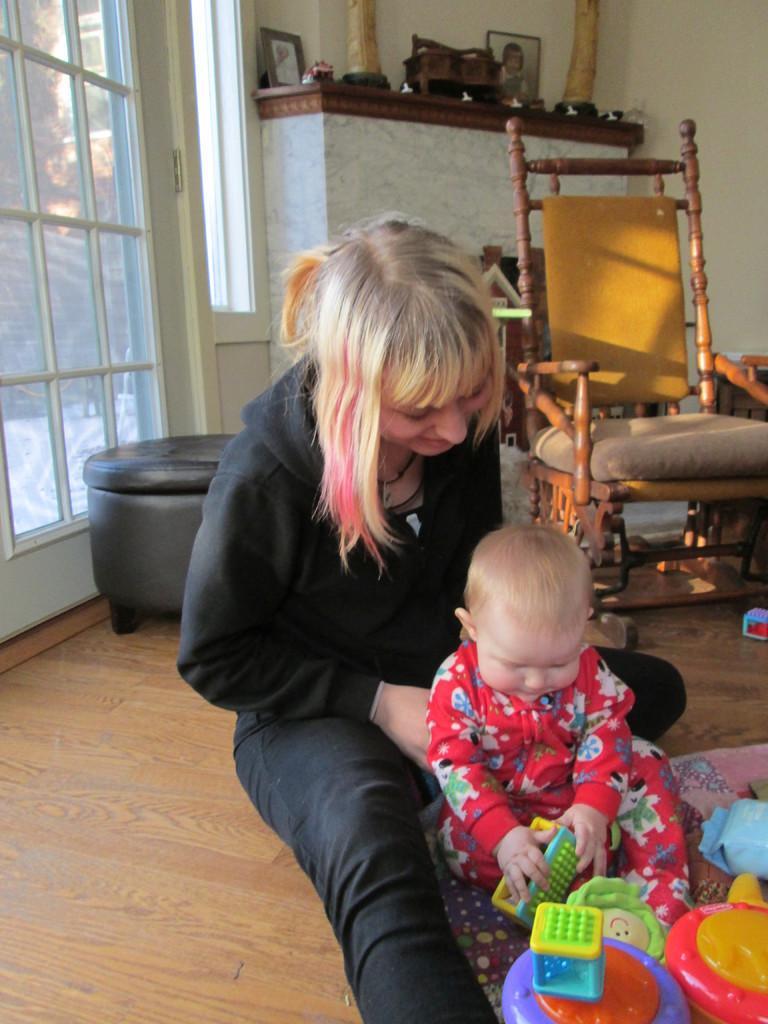Please provide a concise description of this image. This room consists of two persons, a chair and the door on the left side. There are toys in the bottom right corner. There is a photo frame on the top. In the middle there is a woman she is holding a kid in her hand. 